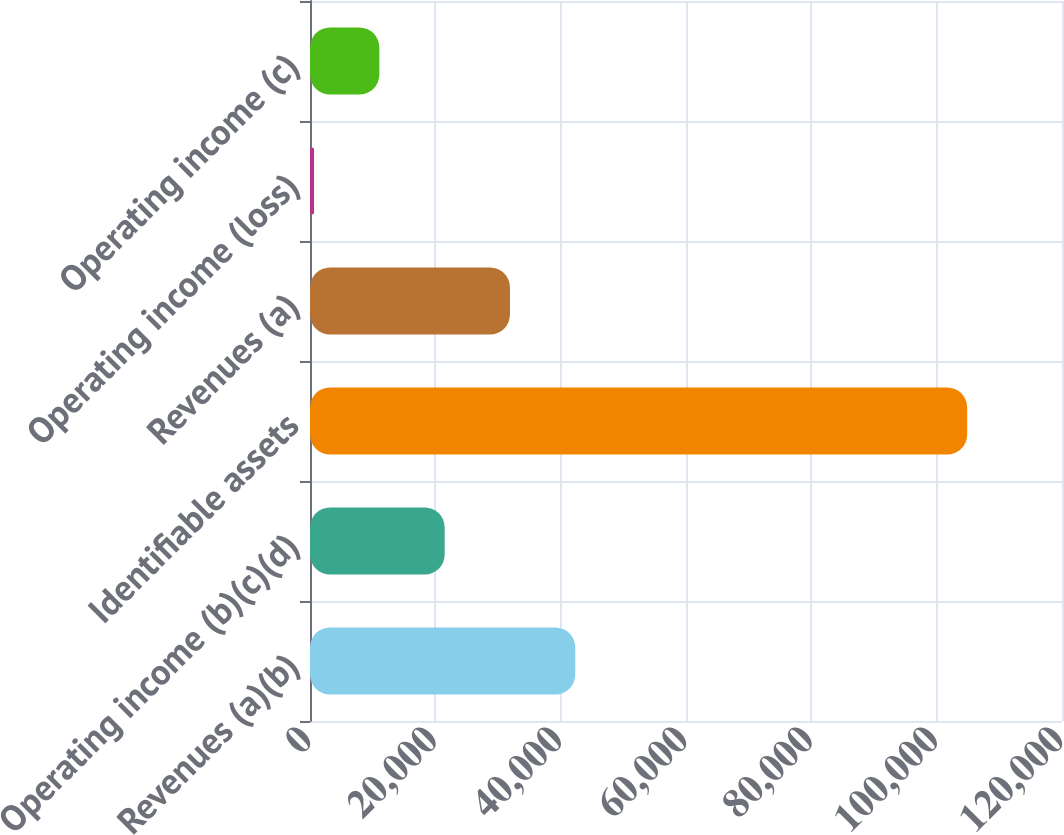Convert chart to OTSL. <chart><loc_0><loc_0><loc_500><loc_500><bar_chart><fcel>Revenues (a)(b)<fcel>Operating income (b)(c)(d)<fcel>Identifiable assets<fcel>Revenues (a)<fcel>Operating income (loss)<fcel>Operating income (c)<nl><fcel>42334<fcel>21490<fcel>104866<fcel>31912<fcel>646<fcel>11068<nl></chart> 